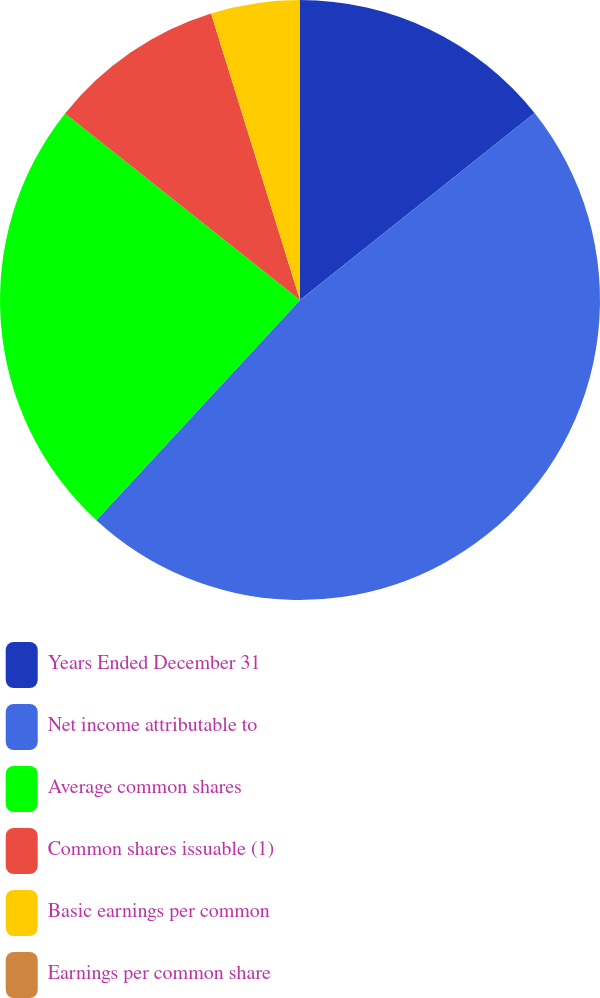Convert chart. <chart><loc_0><loc_0><loc_500><loc_500><pie_chart><fcel>Years Ended December 31<fcel>Net income attributable to<fcel>Average common shares<fcel>Common shares issuable (1)<fcel>Basic earnings per common<fcel>Earnings per common share<nl><fcel>14.29%<fcel>47.59%<fcel>23.8%<fcel>9.53%<fcel>4.77%<fcel>0.02%<nl></chart> 